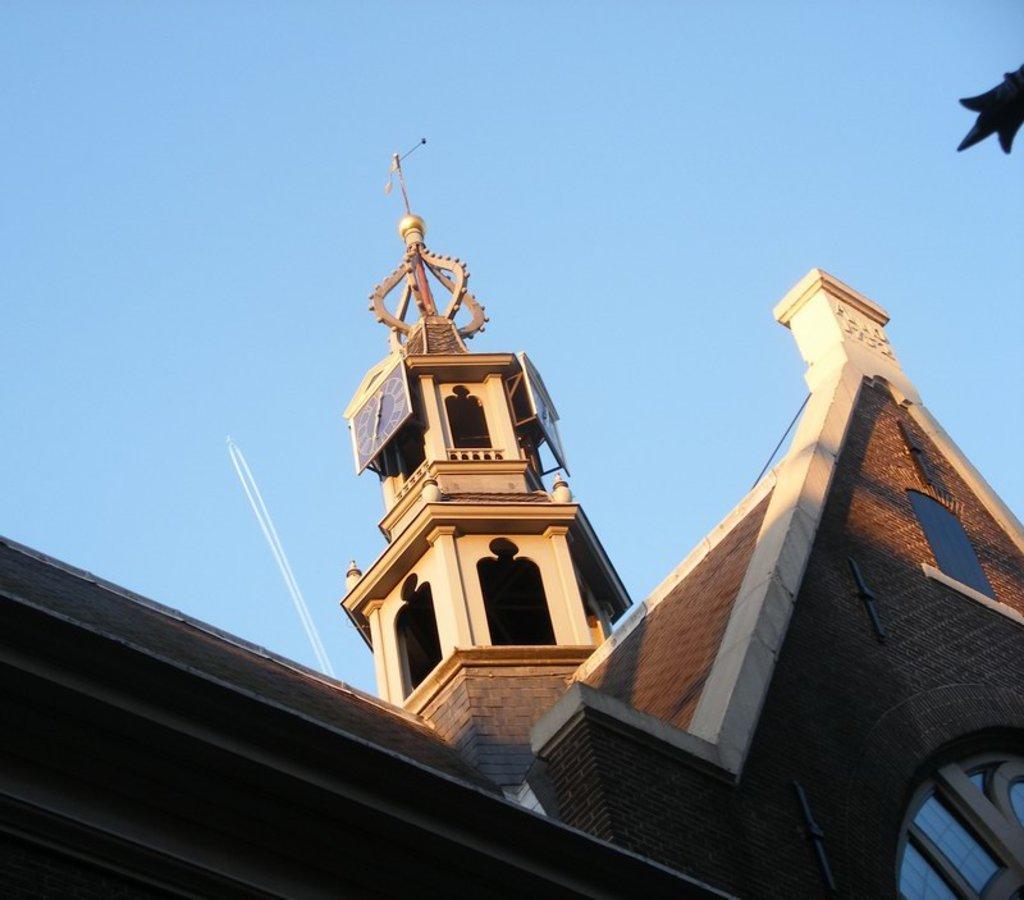Could you give a brief overview of what you see in this image? This is an outside view. Here I can see a building and a tower. On the top of the image I can see the sky. 